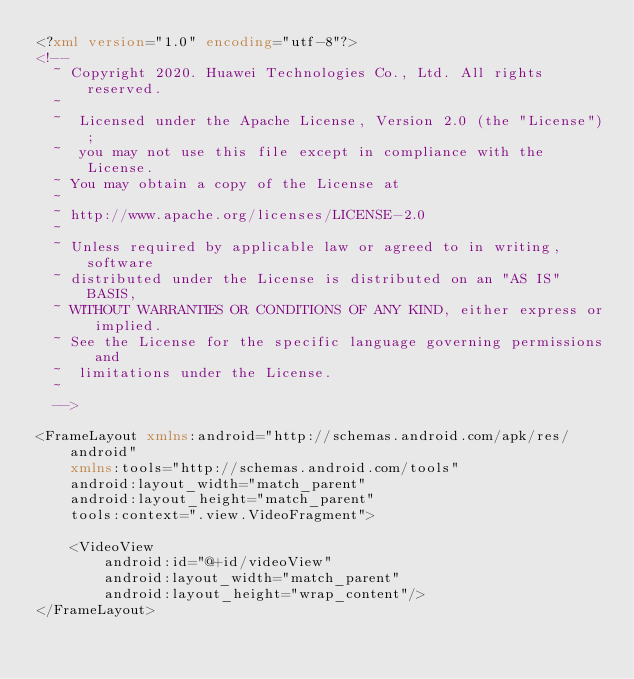Convert code to text. <code><loc_0><loc_0><loc_500><loc_500><_XML_><?xml version="1.0" encoding="utf-8"?>
<!--
  ~ Copyright 2020. Huawei Technologies Co., Ltd. All rights reserved.
  ~
  ~  Licensed under the Apache License, Version 2.0 (the "License");
  ~  you may not use this file except in compliance with the License.
  ~ You may obtain a copy of the License at
  ~
  ~ http://www.apache.org/licenses/LICENSE-2.0
  ~
  ~ Unless required by applicable law or agreed to in writing, software
  ~ distributed under the License is distributed on an "AS IS" BASIS,
  ~ WITHOUT WARRANTIES OR CONDITIONS OF ANY KIND, either express or implied.
  ~ See the License for the specific language governing permissions and
  ~  limitations under the License.
  ~
  -->

<FrameLayout xmlns:android="http://schemas.android.com/apk/res/android"
    xmlns:tools="http://schemas.android.com/tools"
    android:layout_width="match_parent"
    android:layout_height="match_parent"
    tools:context=".view.VideoFragment">

    <VideoView
        android:id="@+id/videoView"
        android:layout_width="match_parent"
        android:layout_height="wrap_content"/>
</FrameLayout></code> 